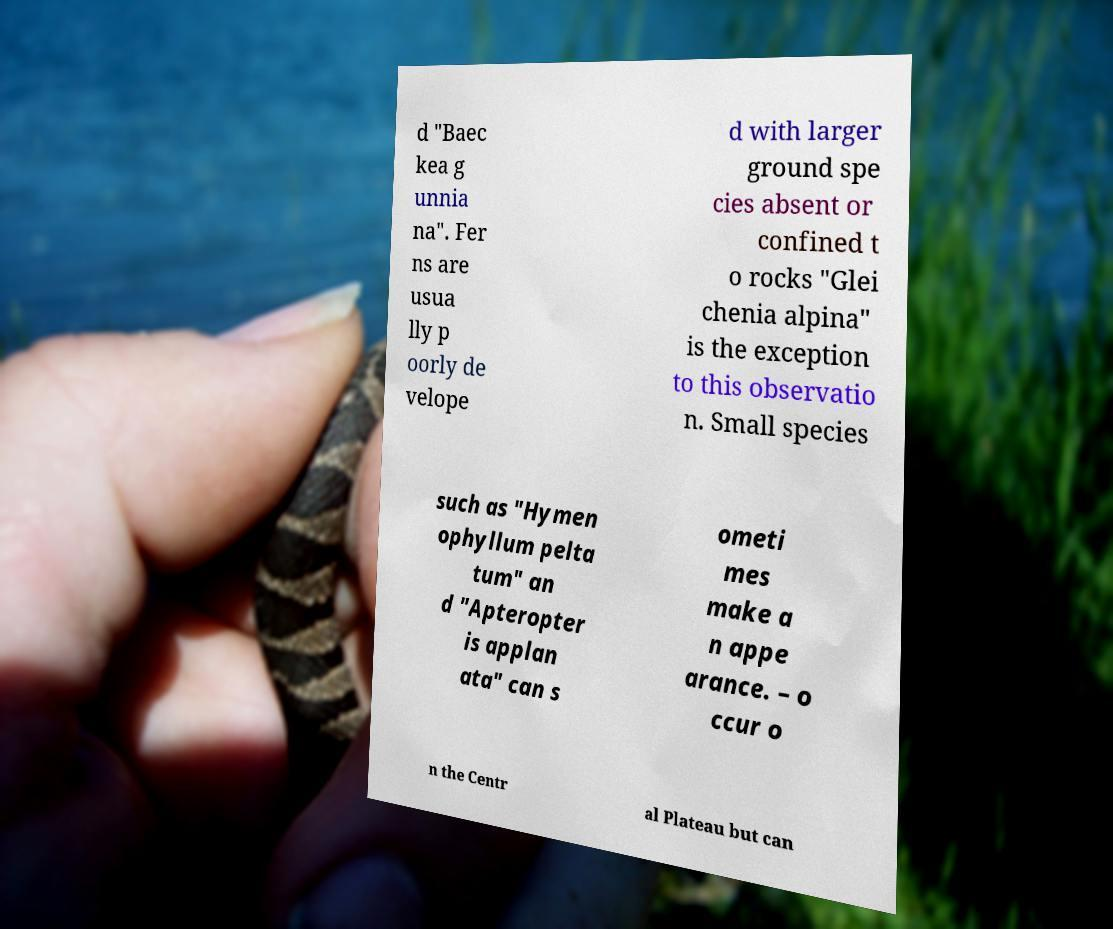Could you assist in decoding the text presented in this image and type it out clearly? d "Baec kea g unnia na". Fer ns are usua lly p oorly de velope d with larger ground spe cies absent or confined t o rocks "Glei chenia alpina" is the exception to this observatio n. Small species such as "Hymen ophyllum pelta tum" an d "Apteropter is applan ata" can s ometi mes make a n appe arance. – o ccur o n the Centr al Plateau but can 